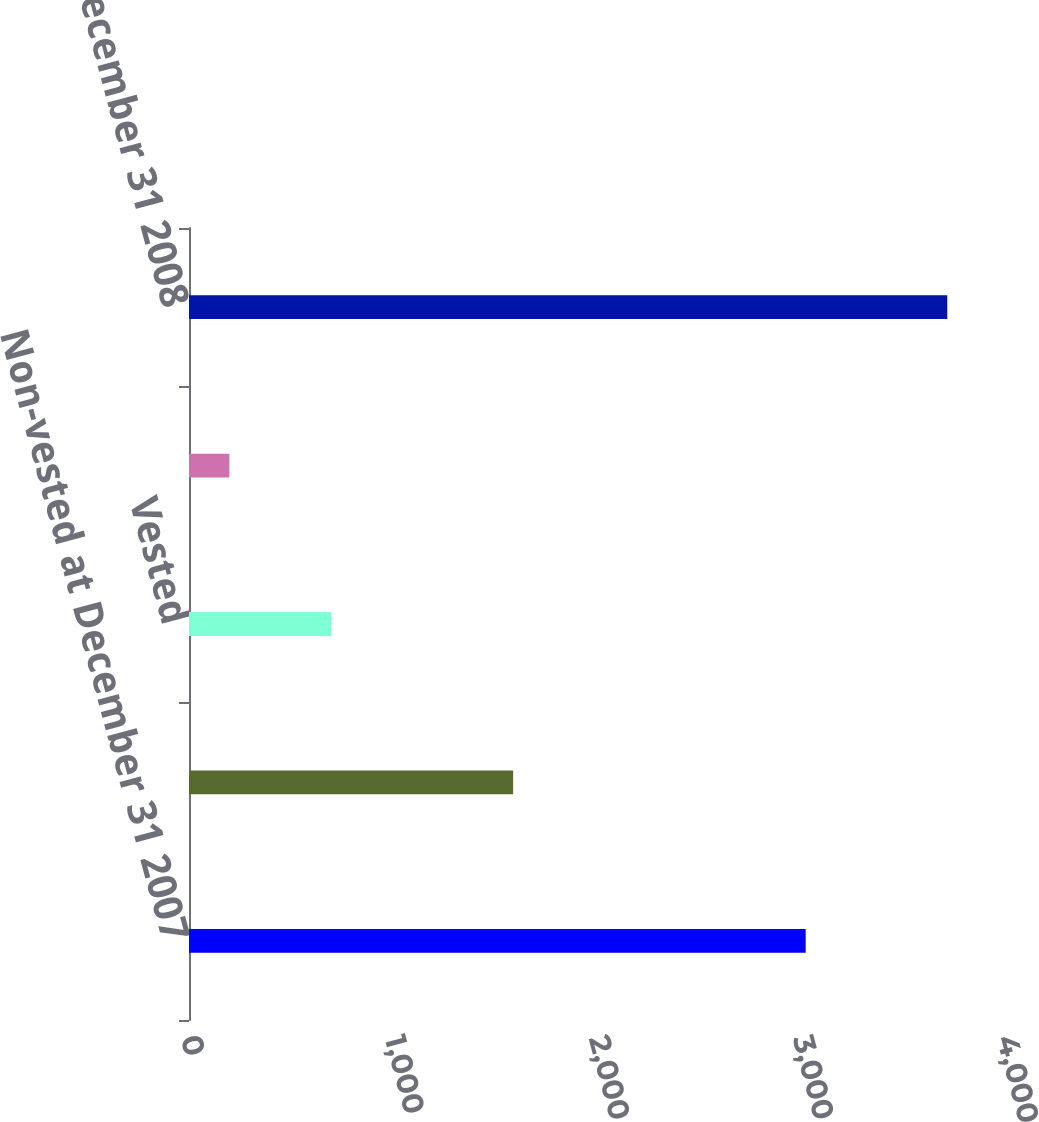Convert chart. <chart><loc_0><loc_0><loc_500><loc_500><bar_chart><fcel>Non-vested at December 31 2007<fcel>Granted<fcel>Vested<fcel>Forfeited<fcel>Non-vested at December 31 2008<nl><fcel>3023<fcel>1589<fcel>697<fcel>198<fcel>3717<nl></chart> 